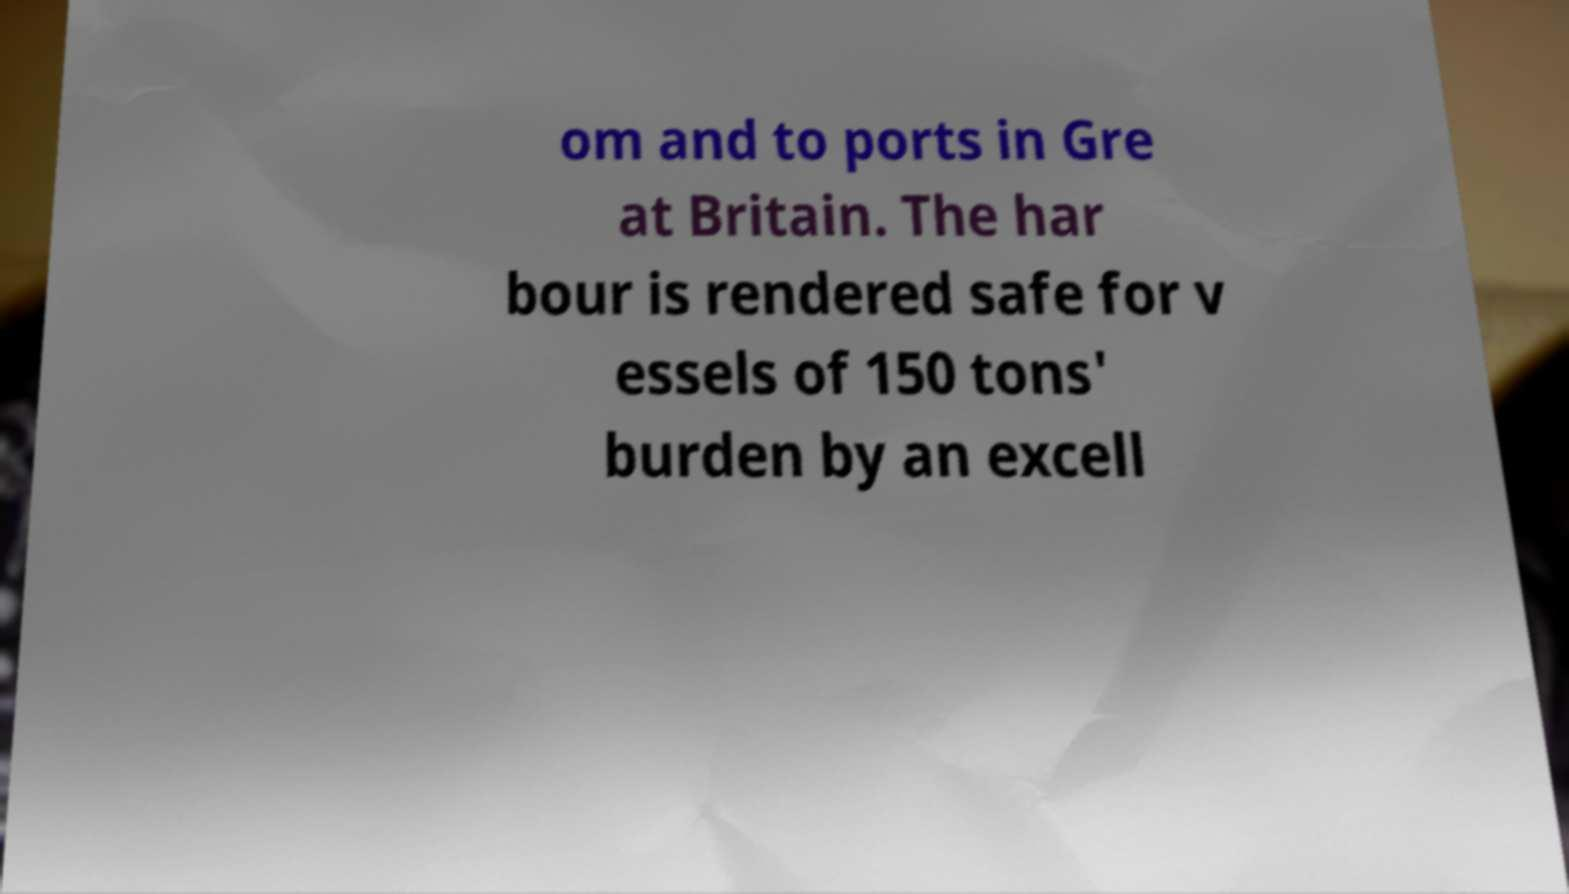Please identify and transcribe the text found in this image. om and to ports in Gre at Britain. The har bour is rendered safe for v essels of 150 tons' burden by an excell 